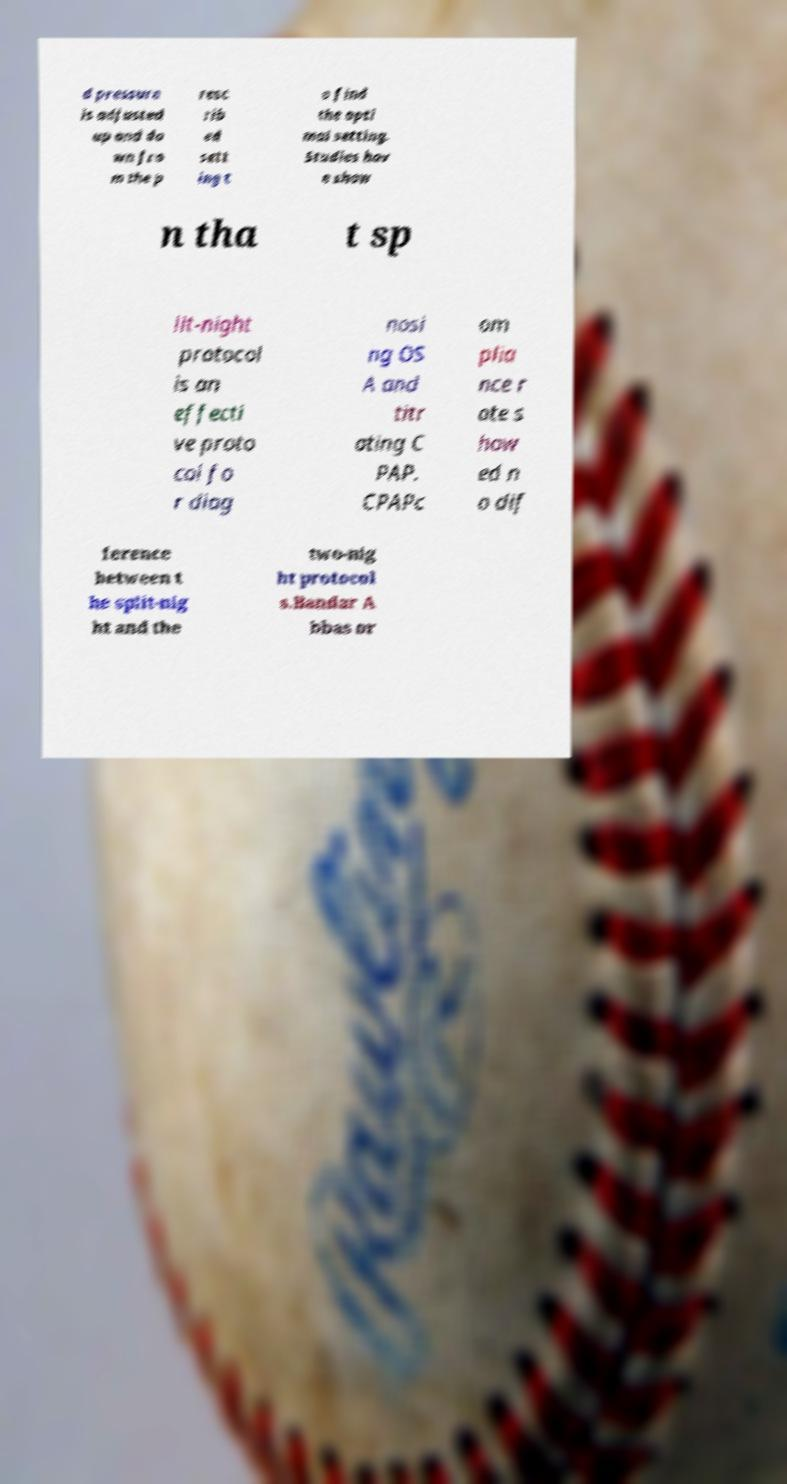Can you accurately transcribe the text from the provided image for me? d pressure is adjusted up and do wn fro m the p resc rib ed sett ing t o find the opti mal setting. Studies hav e show n tha t sp lit-night protocol is an effecti ve proto col fo r diag nosi ng OS A and titr ating C PAP. CPAPc om plia nce r ate s how ed n o dif ference between t he split-nig ht and the two-nig ht protocol s.Bandar A bbas or 